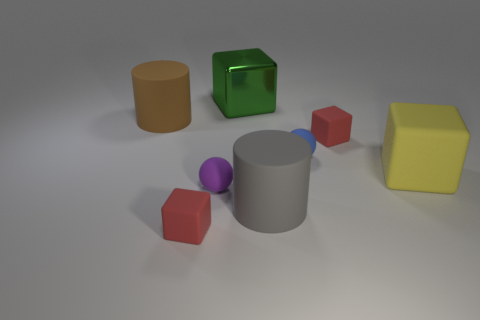Subtract all big rubber cubes. How many cubes are left? 3 Add 1 large yellow matte blocks. How many objects exist? 9 Subtract 2 cubes. How many cubes are left? 2 Subtract all blue spheres. How many red cubes are left? 2 Subtract all yellow cubes. How many cubes are left? 3 Subtract all cylinders. How many objects are left? 6 Subtract 0 cyan cylinders. How many objects are left? 8 Subtract all cyan cubes. Subtract all purple spheres. How many cubes are left? 4 Subtract all big brown metal things. Subtract all gray cylinders. How many objects are left? 7 Add 3 yellow objects. How many yellow objects are left? 4 